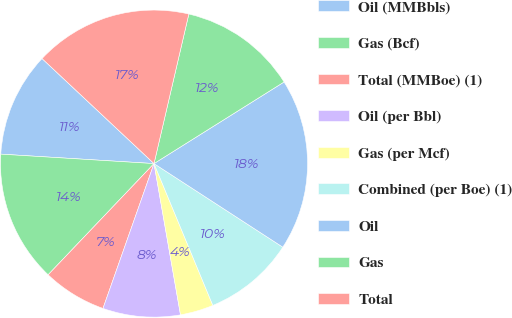Convert chart to OTSL. <chart><loc_0><loc_0><loc_500><loc_500><pie_chart><fcel>Oil (MMBbls)<fcel>Gas (Bcf)<fcel>Total (MMBoe) (1)<fcel>Oil (per Bbl)<fcel>Gas (per Mcf)<fcel>Combined (per Boe) (1)<fcel>Oil<fcel>Gas<fcel>Total<nl><fcel>11.01%<fcel>13.87%<fcel>6.72%<fcel>8.15%<fcel>3.5%<fcel>9.58%<fcel>18.08%<fcel>12.44%<fcel>16.65%<nl></chart> 